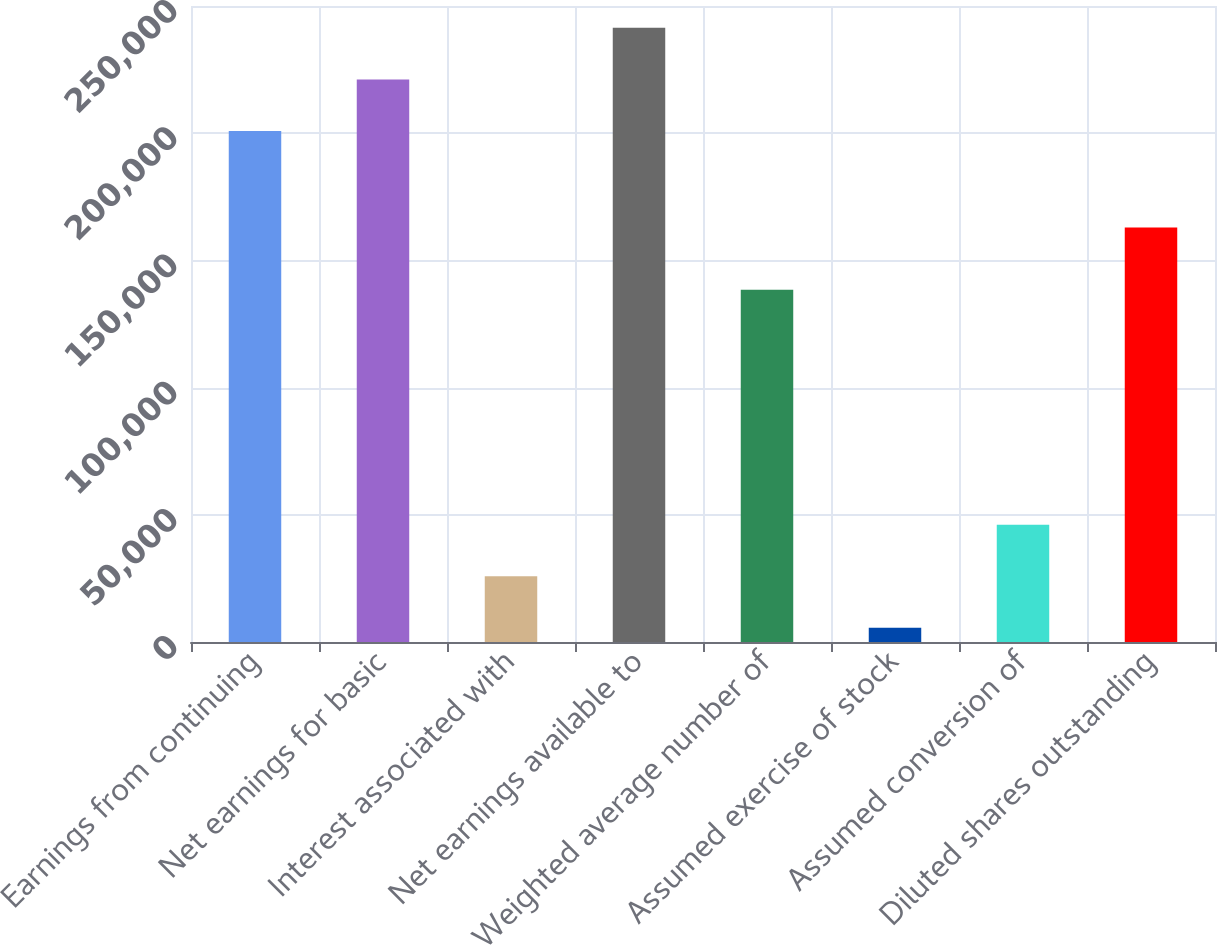<chart> <loc_0><loc_0><loc_500><loc_500><bar_chart><fcel>Earnings from continuing<fcel>Net earnings for basic<fcel>Interest associated with<fcel>Net earnings available to<fcel>Weighted average number of<fcel>Assumed exercise of stock<fcel>Assumed conversion of<fcel>Diluted shares outstanding<nl><fcel>200900<fcel>221156<fcel>25846.9<fcel>241412<fcel>138490<fcel>5591<fcel>46102.8<fcel>162901<nl></chart> 